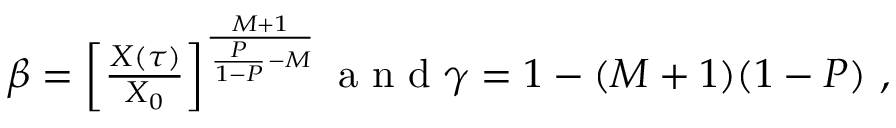Convert formula to latex. <formula><loc_0><loc_0><loc_500><loc_500>\begin{array} { r } { \beta = \left [ \frac { X ( \tau ) } { X _ { 0 } } \right ] ^ { \frac { M + 1 } { \frac { P } { 1 - P } - M } } a n d \gamma = 1 - ( M + 1 ) ( 1 - P ) , } \end{array}</formula> 